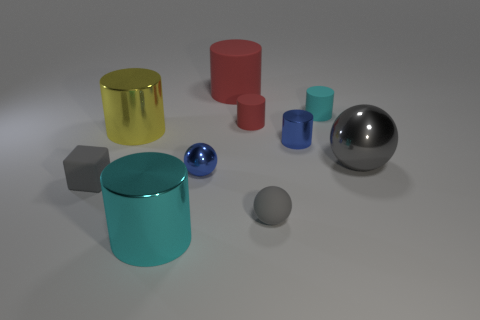Aside from being big, blue, and metallic or red, are there any other objects that stand out to you? Indeed, apart from the big blue metallic cylinder and the red one, a shiny metallic sphere stands out due to its reflective surface that seems to mirror the environment. It adds a contrast to the matte finishes of the other objects and draws attention with its smooth, uninterrupted shape. What does the sphere reflect, anything in particular? The metallic sphere reflects the light source and some of the objects around it. As an observer, you can infer the position of the light source and gain a better understanding of the spatial relation among the items thanks to the reflections on its surface. 